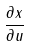<formula> <loc_0><loc_0><loc_500><loc_500>\frac { \partial x } { \partial u }</formula> 